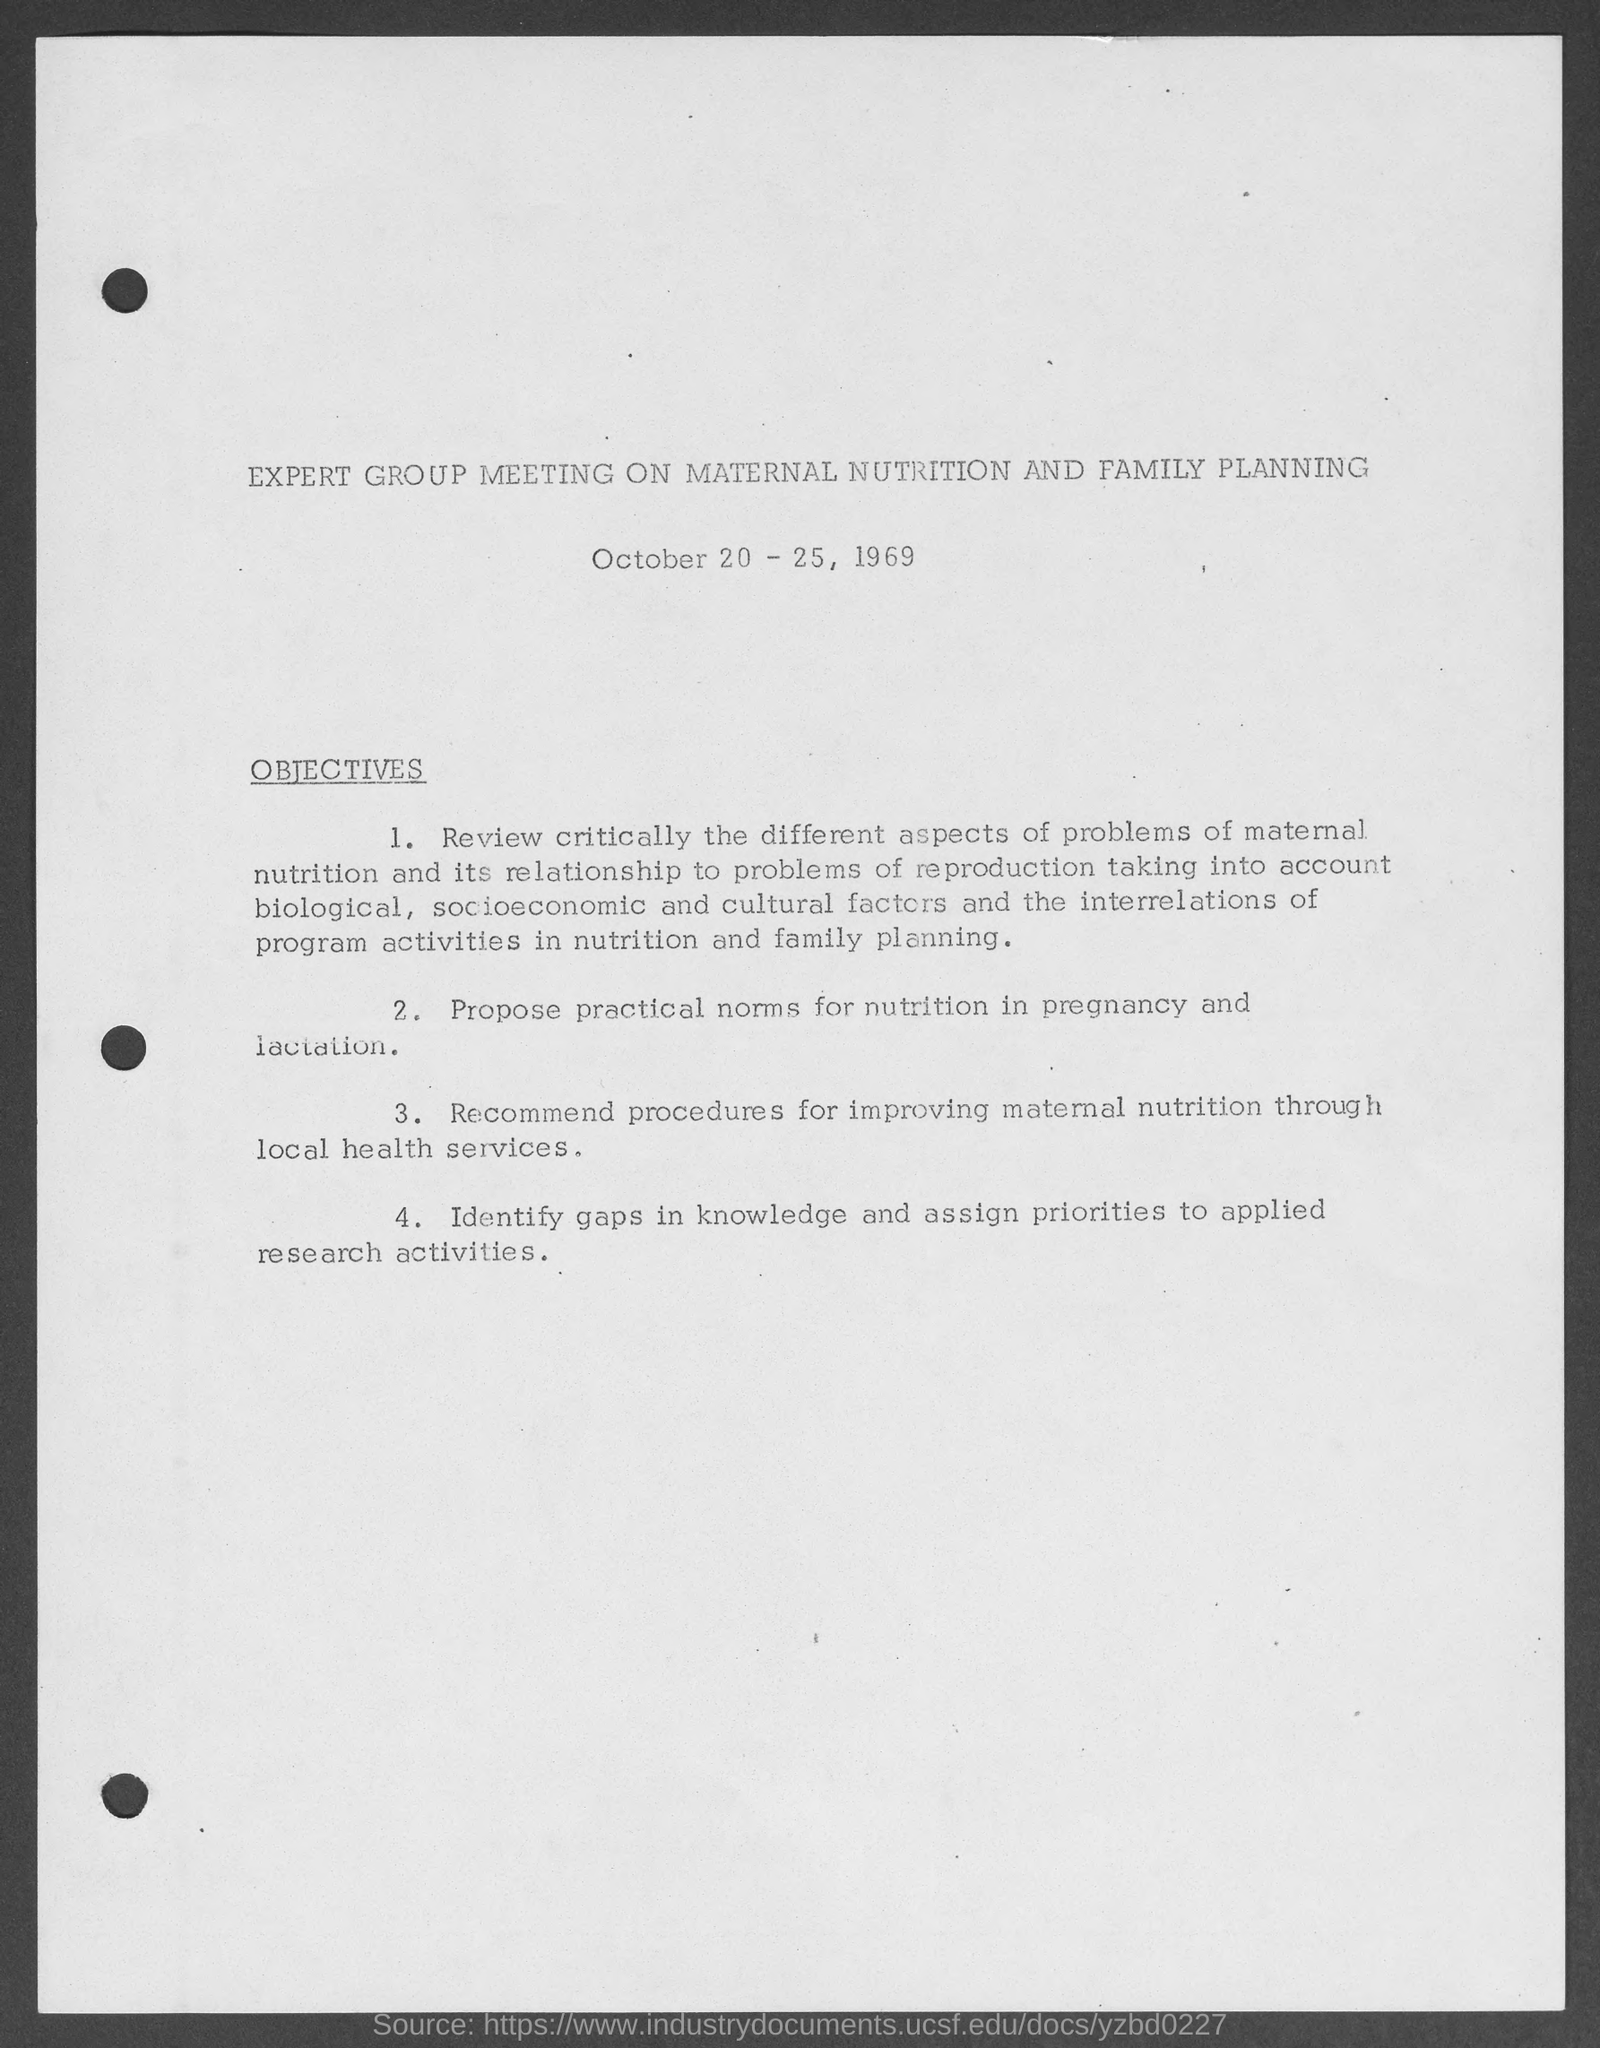What is the meeting about?
Make the answer very short. EXPERT GROUP MEETING ON MATERNAL NUTRITION AND FAMILY PLANNING. When is the meeting?
Make the answer very short. October 20 - 25, 1969. 